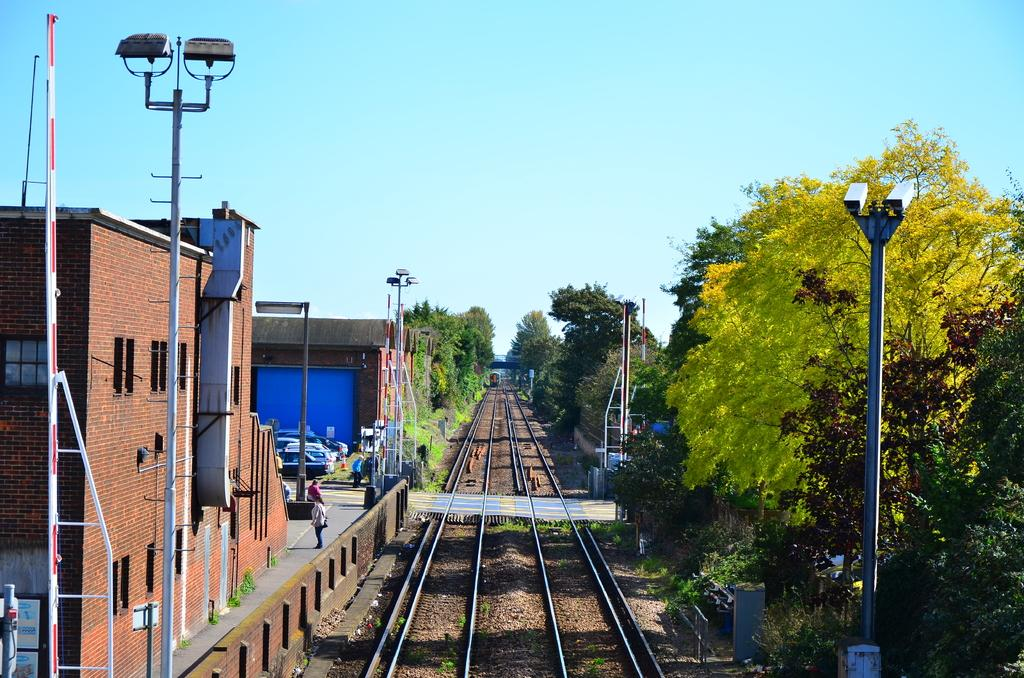What structures can be seen in the image? There are light poles and buildings visible in the image. What type of surface can be seen in the image? There are tracks in the image. What color are the trees in the image? The trees in the image have green color. What color are the buildings in the image? The buildings in the image have brown color. What can be seen in the background of the image? The sky in the background is blue. Where is the lunchroom located in the image? There is no lunchroom present in the image. What type of mass can be seen in the image? There is no mass visible in the image. 